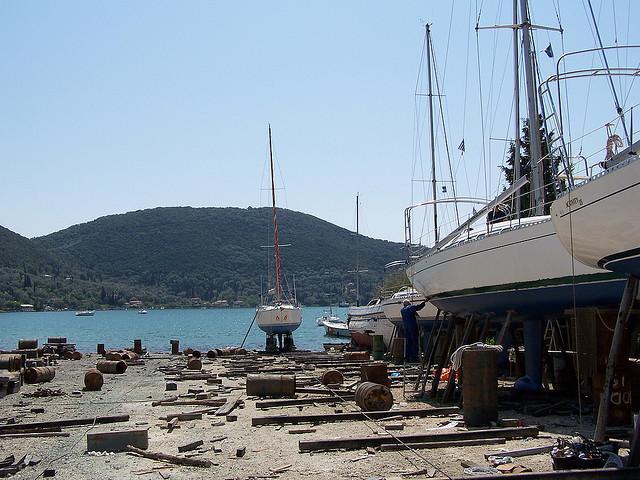How many mountains are pictured?
Give a very brief answer. 2. How many elephants are in the picture?
Give a very brief answer. 0. 